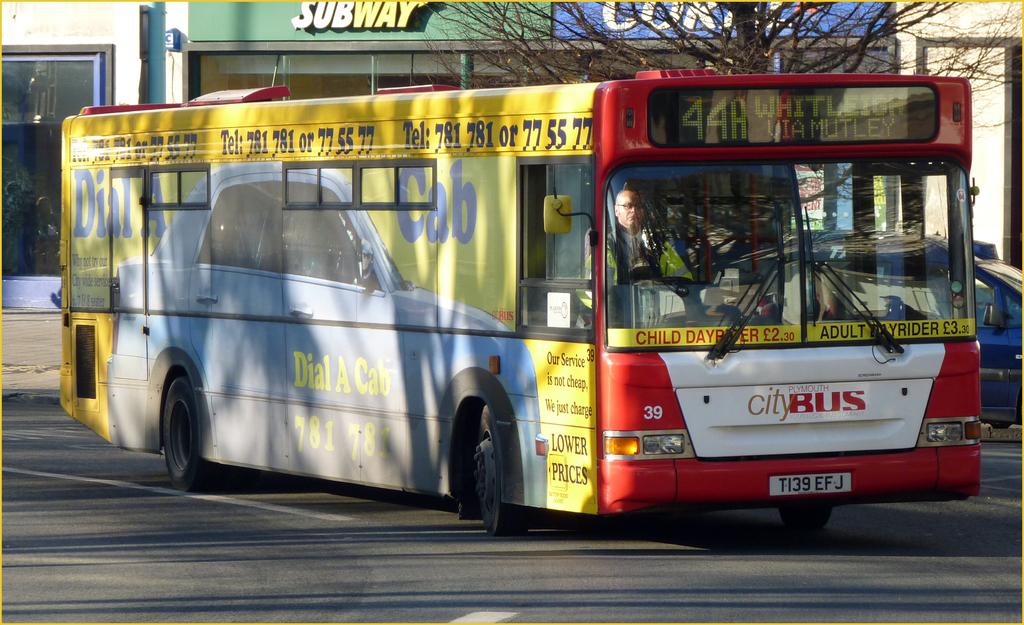What is the main subject of the image? The main subject of the image is a bus. What is the bus doing in the image? The bus is moving on the road. Who is controlling the bus? A person is driving the bus. What can be seen in the top right corner of the image? There is a tree at the top right corner of the image. What type of vegetable is being used as a basketball in the image? There is no vegetable or basketball present in the image. 